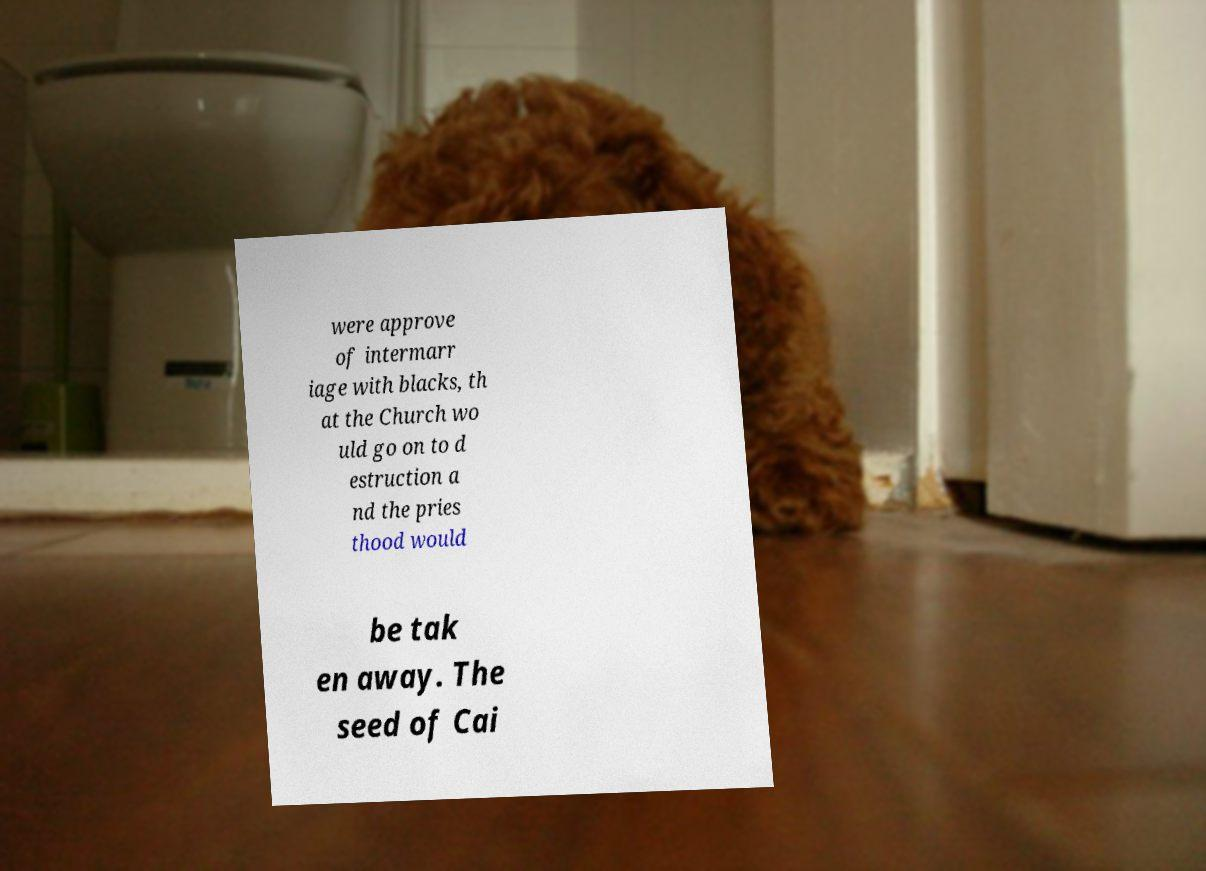Please read and relay the text visible in this image. What does it say? were approve of intermarr iage with blacks, th at the Church wo uld go on to d estruction a nd the pries thood would be tak en away. The seed of Cai 